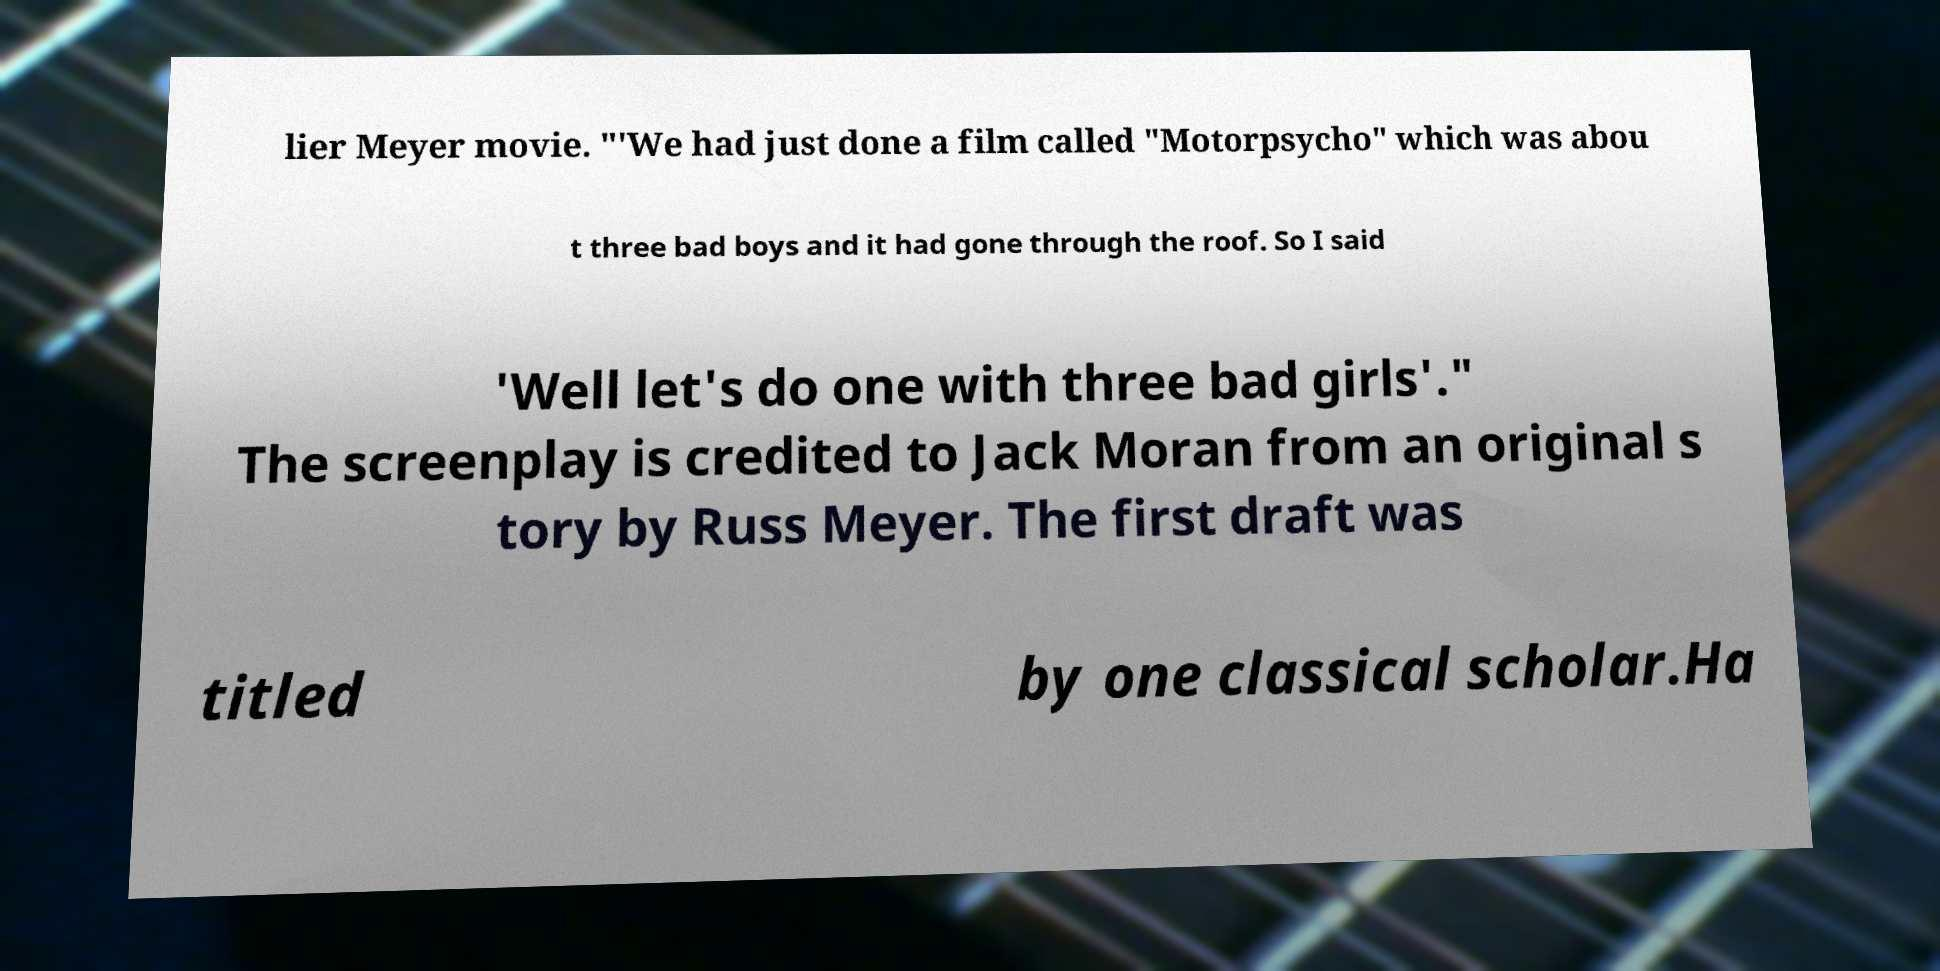Please read and relay the text visible in this image. What does it say? lier Meyer movie. "'We had just done a film called "Motorpsycho" which was abou t three bad boys and it had gone through the roof. So I said 'Well let's do one with three bad girls'." The screenplay is credited to Jack Moran from an original s tory by Russ Meyer. The first draft was titled by one classical scholar.Ha 